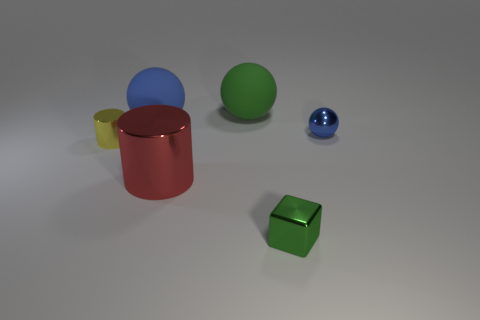Is the shape of the tiny thing to the right of the metal block the same as  the green rubber object?
Make the answer very short. Yes. The other rubber thing that is the same shape as the large green matte thing is what size?
Your answer should be compact. Large. Do the blue rubber thing and the green rubber thing have the same shape?
Make the answer very short. Yes. The other small object that is the same shape as the red metallic object is what color?
Offer a terse response. Yellow. Is the size of the green matte sphere the same as the red shiny object?
Your response must be concise. Yes. There is a small object that is on the right side of the blue rubber sphere and behind the large red thing; what is its color?
Provide a succinct answer. Blue. How many green cubes are the same material as the big cylinder?
Offer a terse response. 1. How many blue rubber objects are there?
Your response must be concise. 1. There is a yellow thing; is its size the same as the ball that is left of the green matte thing?
Make the answer very short. No. There is a big thing in front of the blue ball that is on the left side of the small green metallic cube; what is its material?
Provide a succinct answer. Metal. 